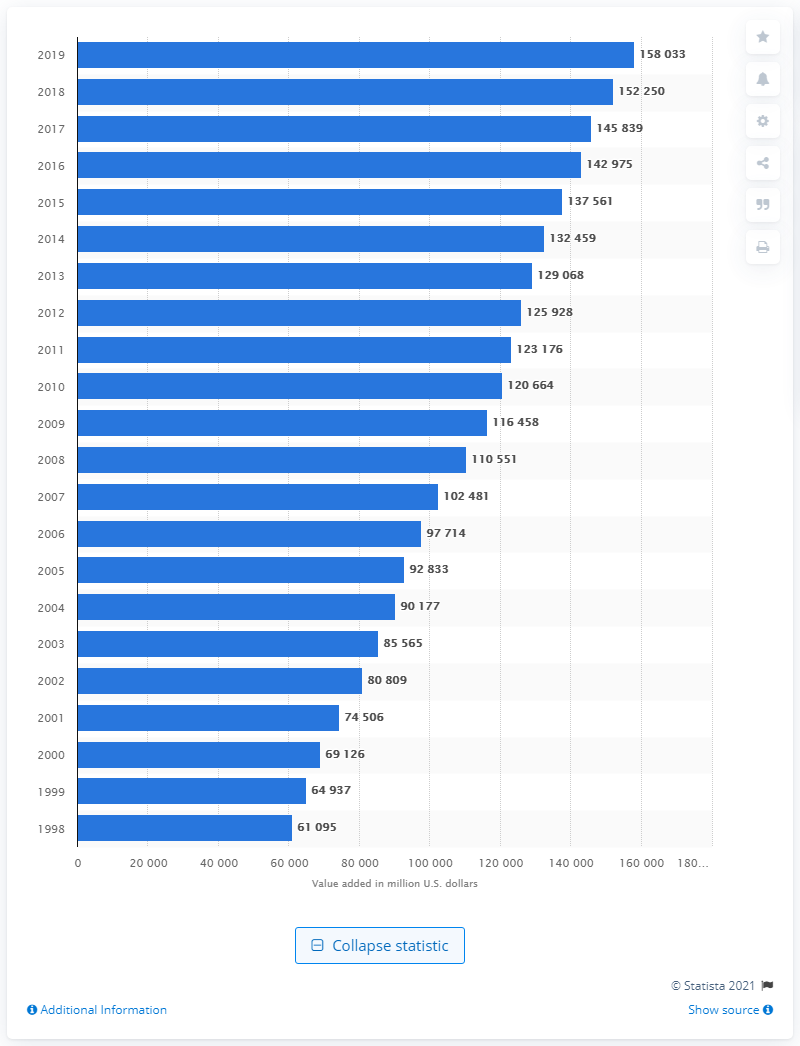List a handful of essential elements in this visual. In 1998, the value added by hospitals and nursing and residential care facilities was 61095. 